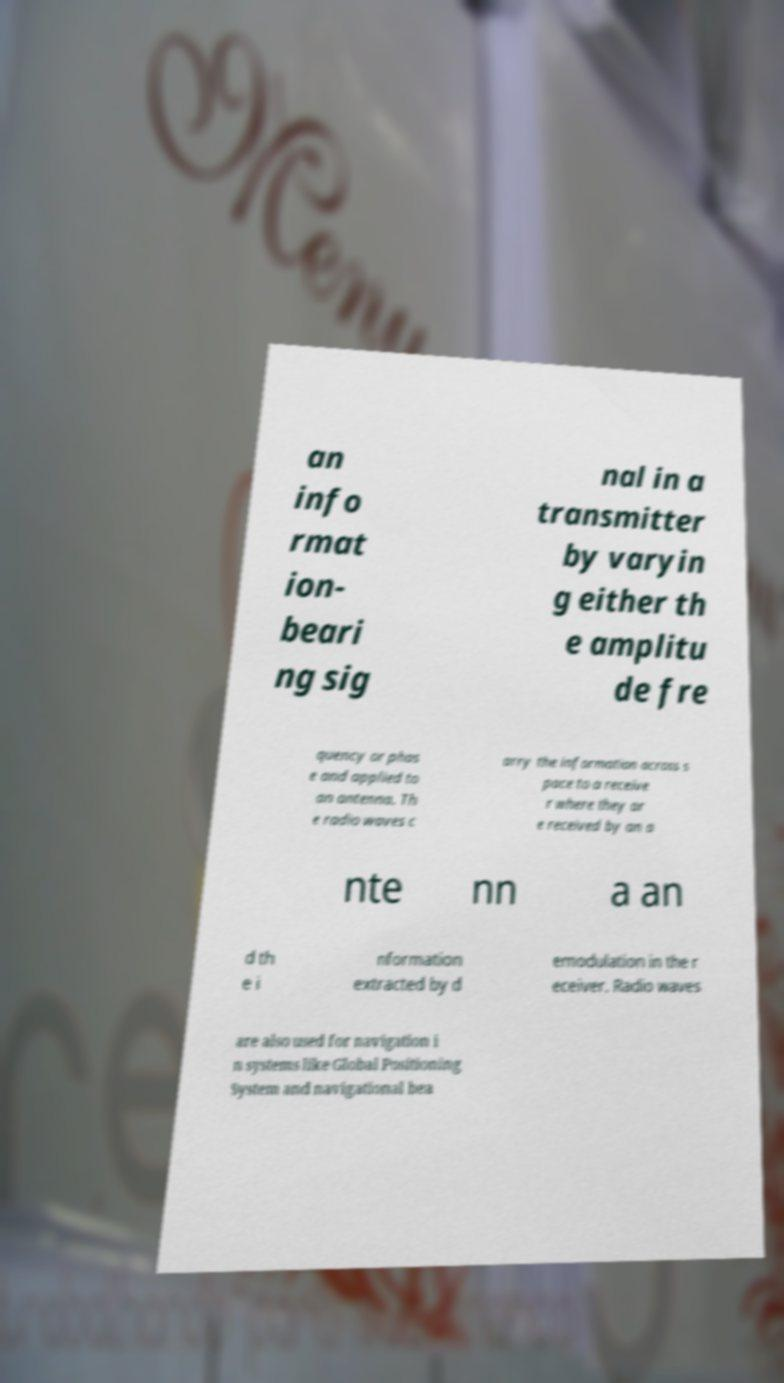What messages or text are displayed in this image? I need them in a readable, typed format. an info rmat ion- beari ng sig nal in a transmitter by varyin g either th e amplitu de fre quency or phas e and applied to an antenna. Th e radio waves c arry the information across s pace to a receive r where they ar e received by an a nte nn a an d th e i nformation extracted by d emodulation in the r eceiver. Radio waves are also used for navigation i n systems like Global Positioning System and navigational bea 